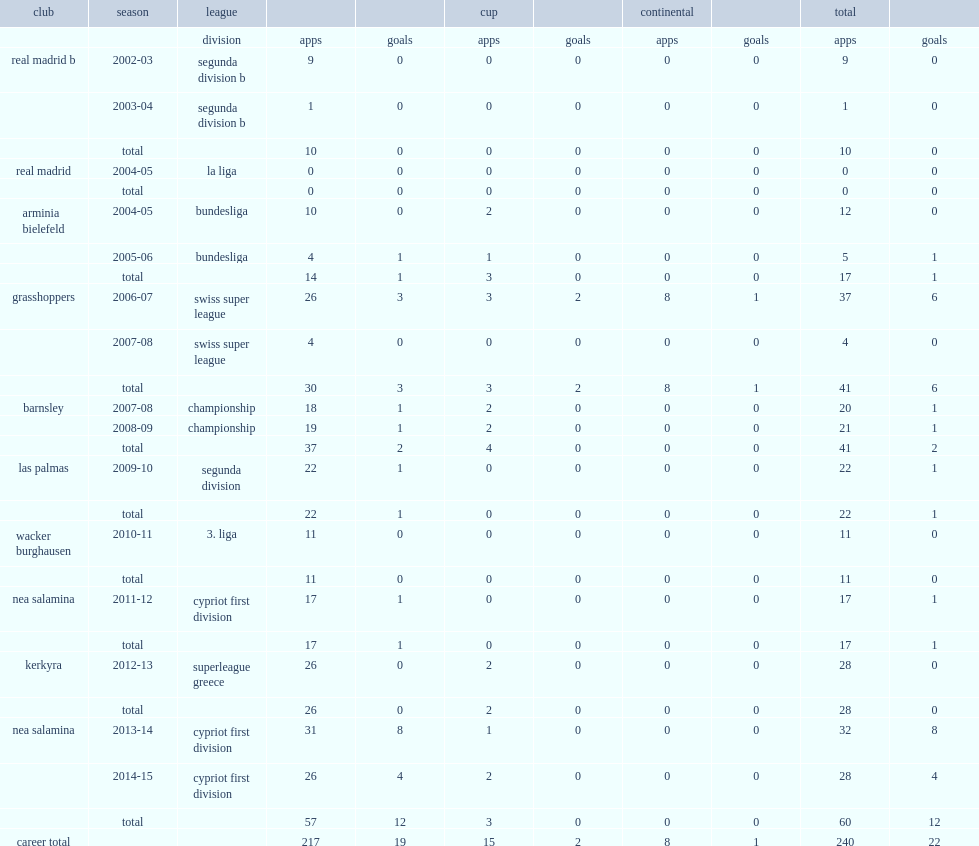Which league did diego leon appear for barnsley in 2007-08 season? Championship. 